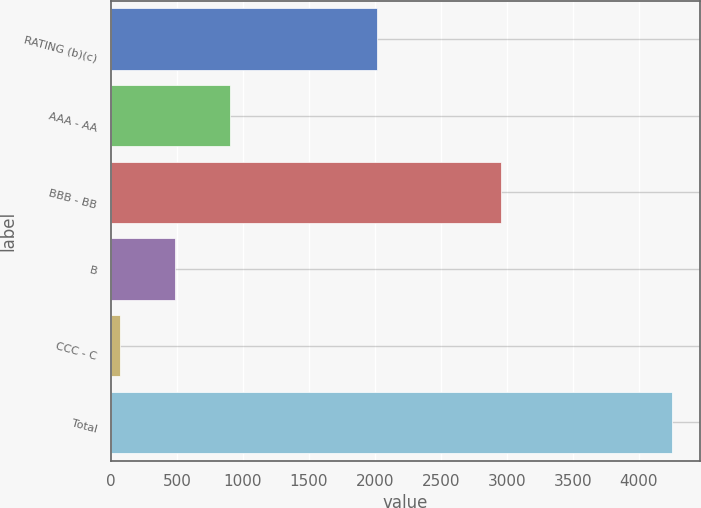<chart> <loc_0><loc_0><loc_500><loc_500><bar_chart><fcel>RATING (b)(c)<fcel>AAA - AA<fcel>BBB - BB<fcel>B<fcel>CCC - C<fcel>Total<nl><fcel>2014<fcel>904<fcel>2952<fcel>485.5<fcel>67<fcel>4252<nl></chart> 